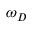Convert formula to latex. <formula><loc_0><loc_0><loc_500><loc_500>\omega _ { D }</formula> 